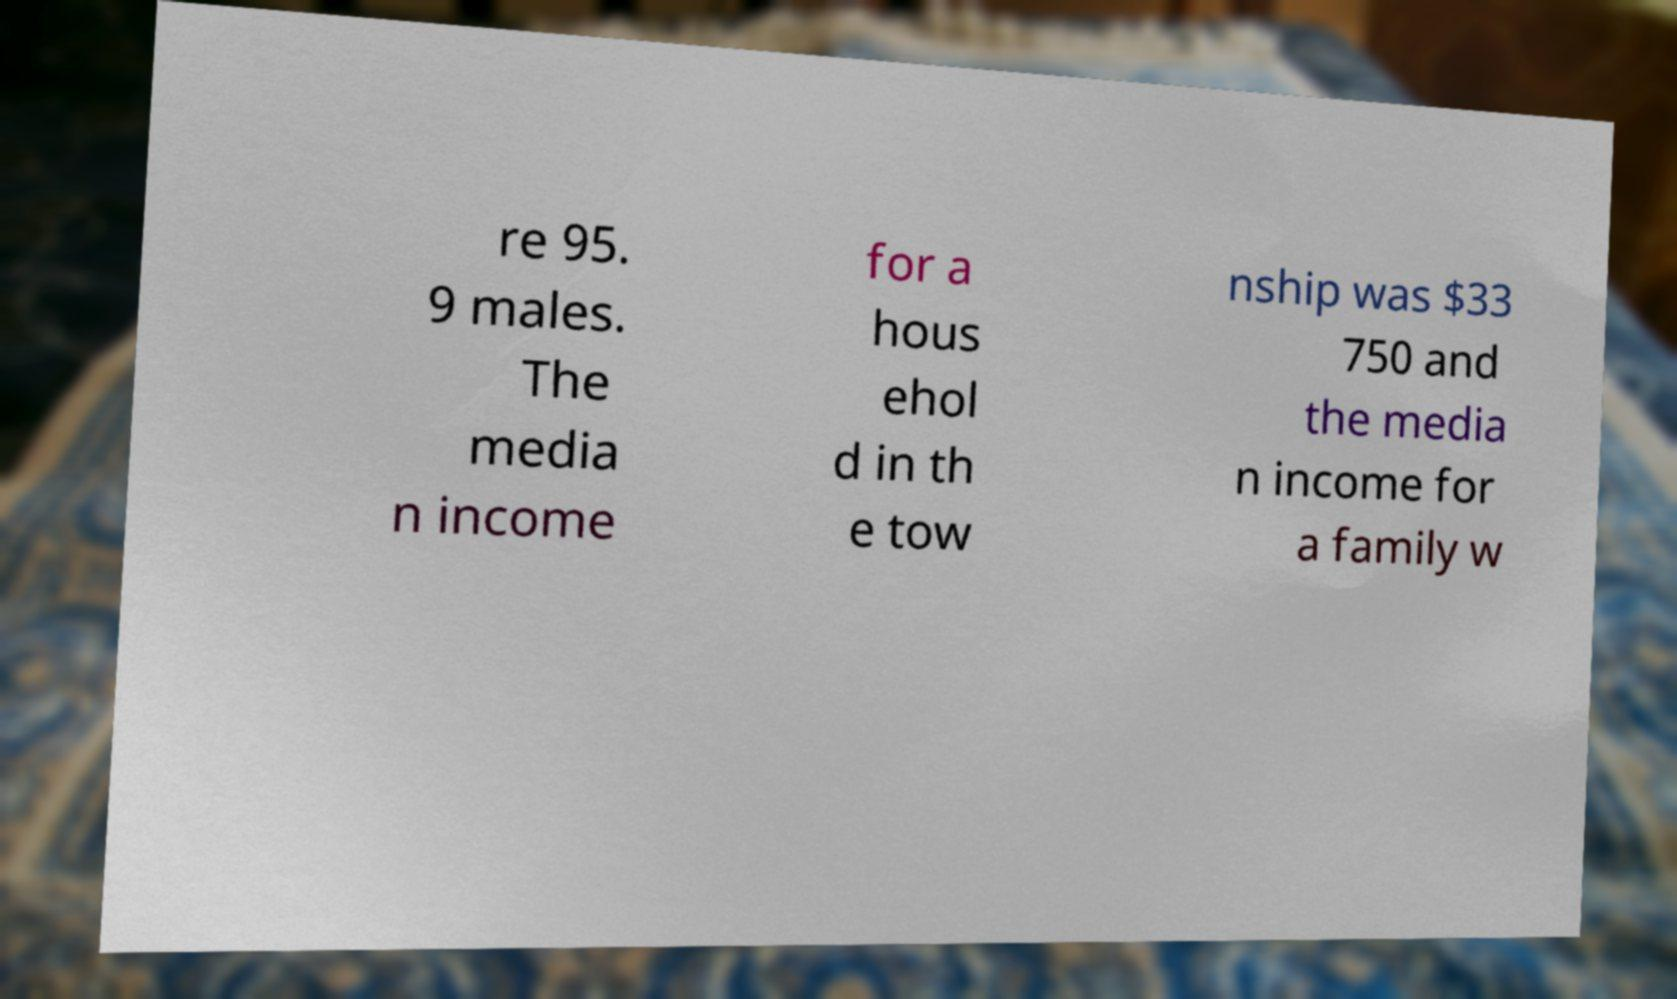Can you read and provide the text displayed in the image?This photo seems to have some interesting text. Can you extract and type it out for me? re 95. 9 males. The media n income for a hous ehol d in th e tow nship was $33 750 and the media n income for a family w 